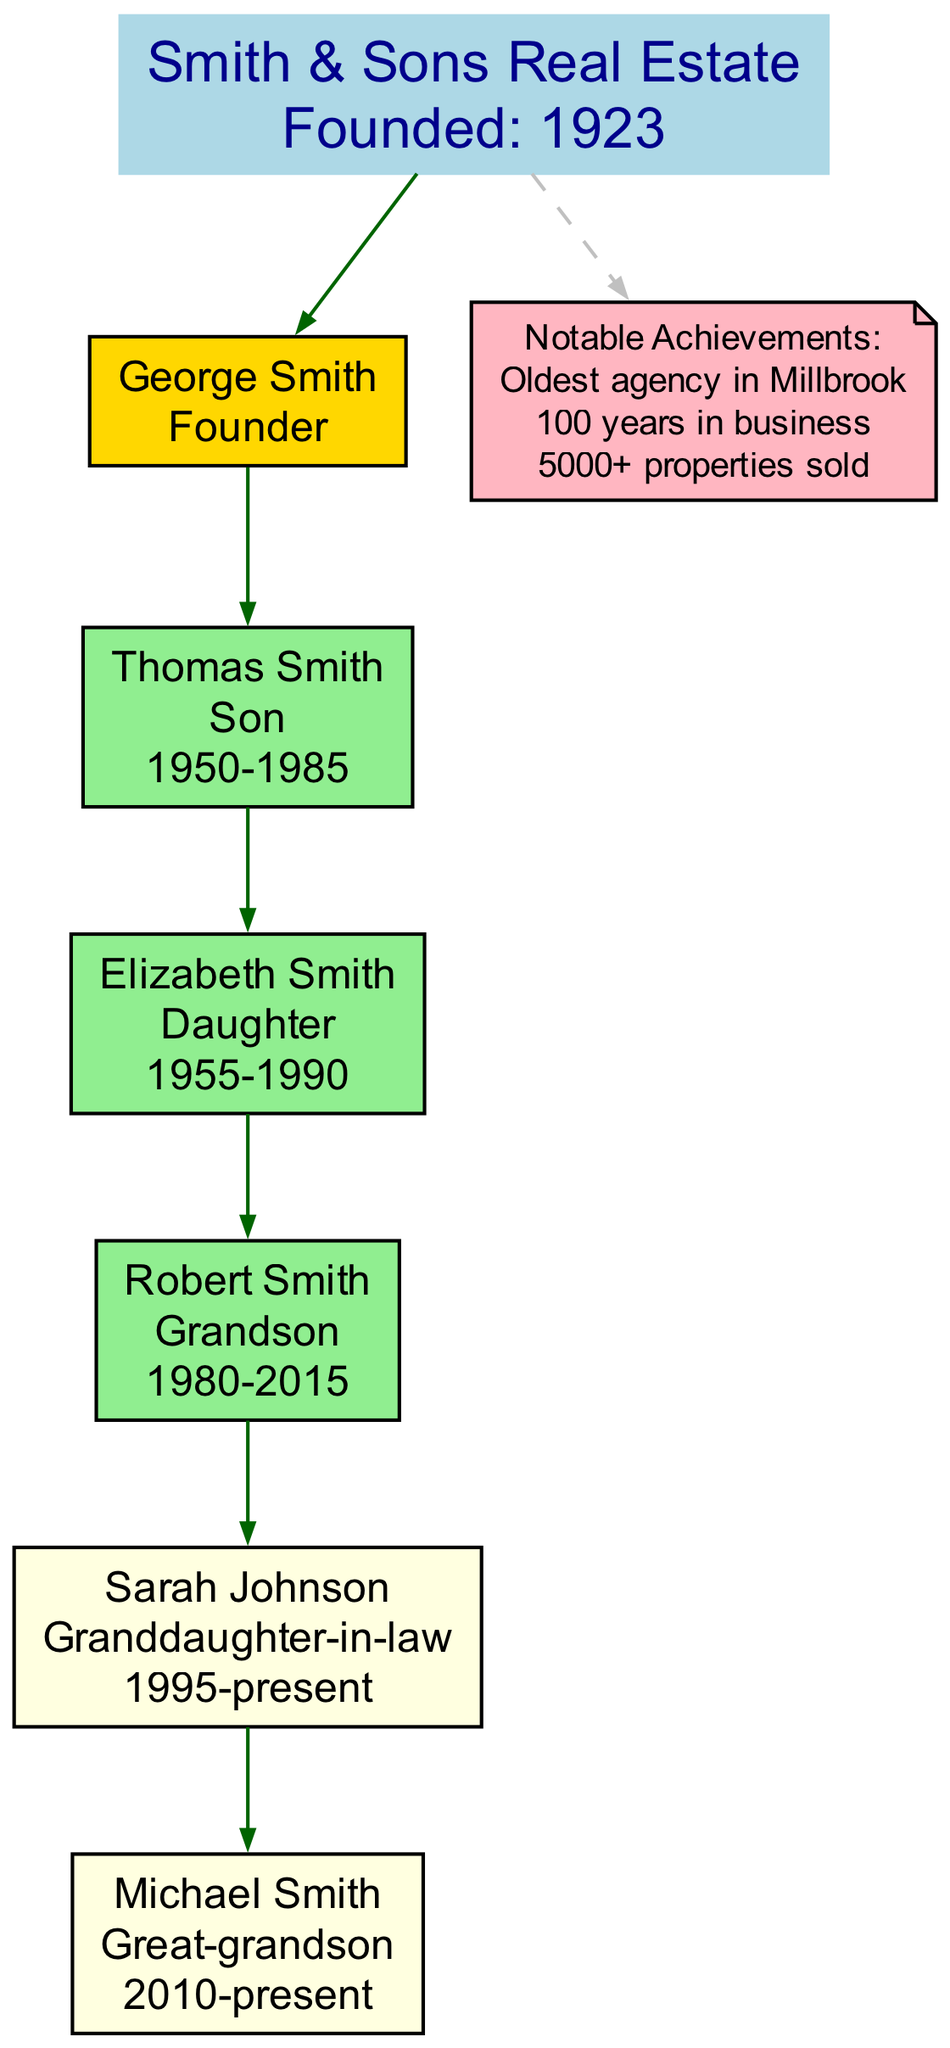What is the name of the founder of the agency? The diagram clearly identifies the founder of the agency as George Smith, which is stated directly under the founder node.
Answer: George Smith In what year was Smith & Sons Real Estate founded? The year of founding is listed right beside the agency name in the diagram; it states "Founded: 1923."
Answer: 1923 How many generations of family members have been active in the agency? The diagram lists five individuals under generations, indicating that there have been five distinct family members (Thomas, Elizabeth, Robert, Sarah, and Michael) who were active in the agency.
Answer: 5 Who is the only granddaughter-in-law mentioned in the diagram? Looking at the diagram, Sarah Johnson is listed as the only granddaughter-in-law among the family members, indicating her specific relation to the lineage.
Answer: Sarah Johnson What are the years of activity for Thomas Smith? By examining the node for Thomas Smith in the diagram, it notes that he was active from 1950 to 1985, which is specified in his label.
Answer: 1950-1985 Which member has been active in the agency the longest? The diagram suggests that George Smith, as the founder, had the longest activity tenure starting from 1923 until his passing, making him the first and earliest family member in operation.
Answer: George Smith Which color indicates a currently active member in the diagram? The diagram employs a light yellow fill color for currently active members, which are Sarah Johnson and Michael Smith's nodes, differentiating them from those who are no longer active.
Answer: Light yellow How many notable achievements are listed under the agency? In the diagram, there are three notable achievements listed under the agency node, clearly indicating key milestones in the agency's history.
Answer: 3 What is one notable achievement of Smith & Sons Real Estate? The diagram provides a specific standout achievement that states "Oldest agency in Millbrook" as one of the notable accomplishments which distinguishes it in the local market.
Answer: Oldest agency in Millbrook 